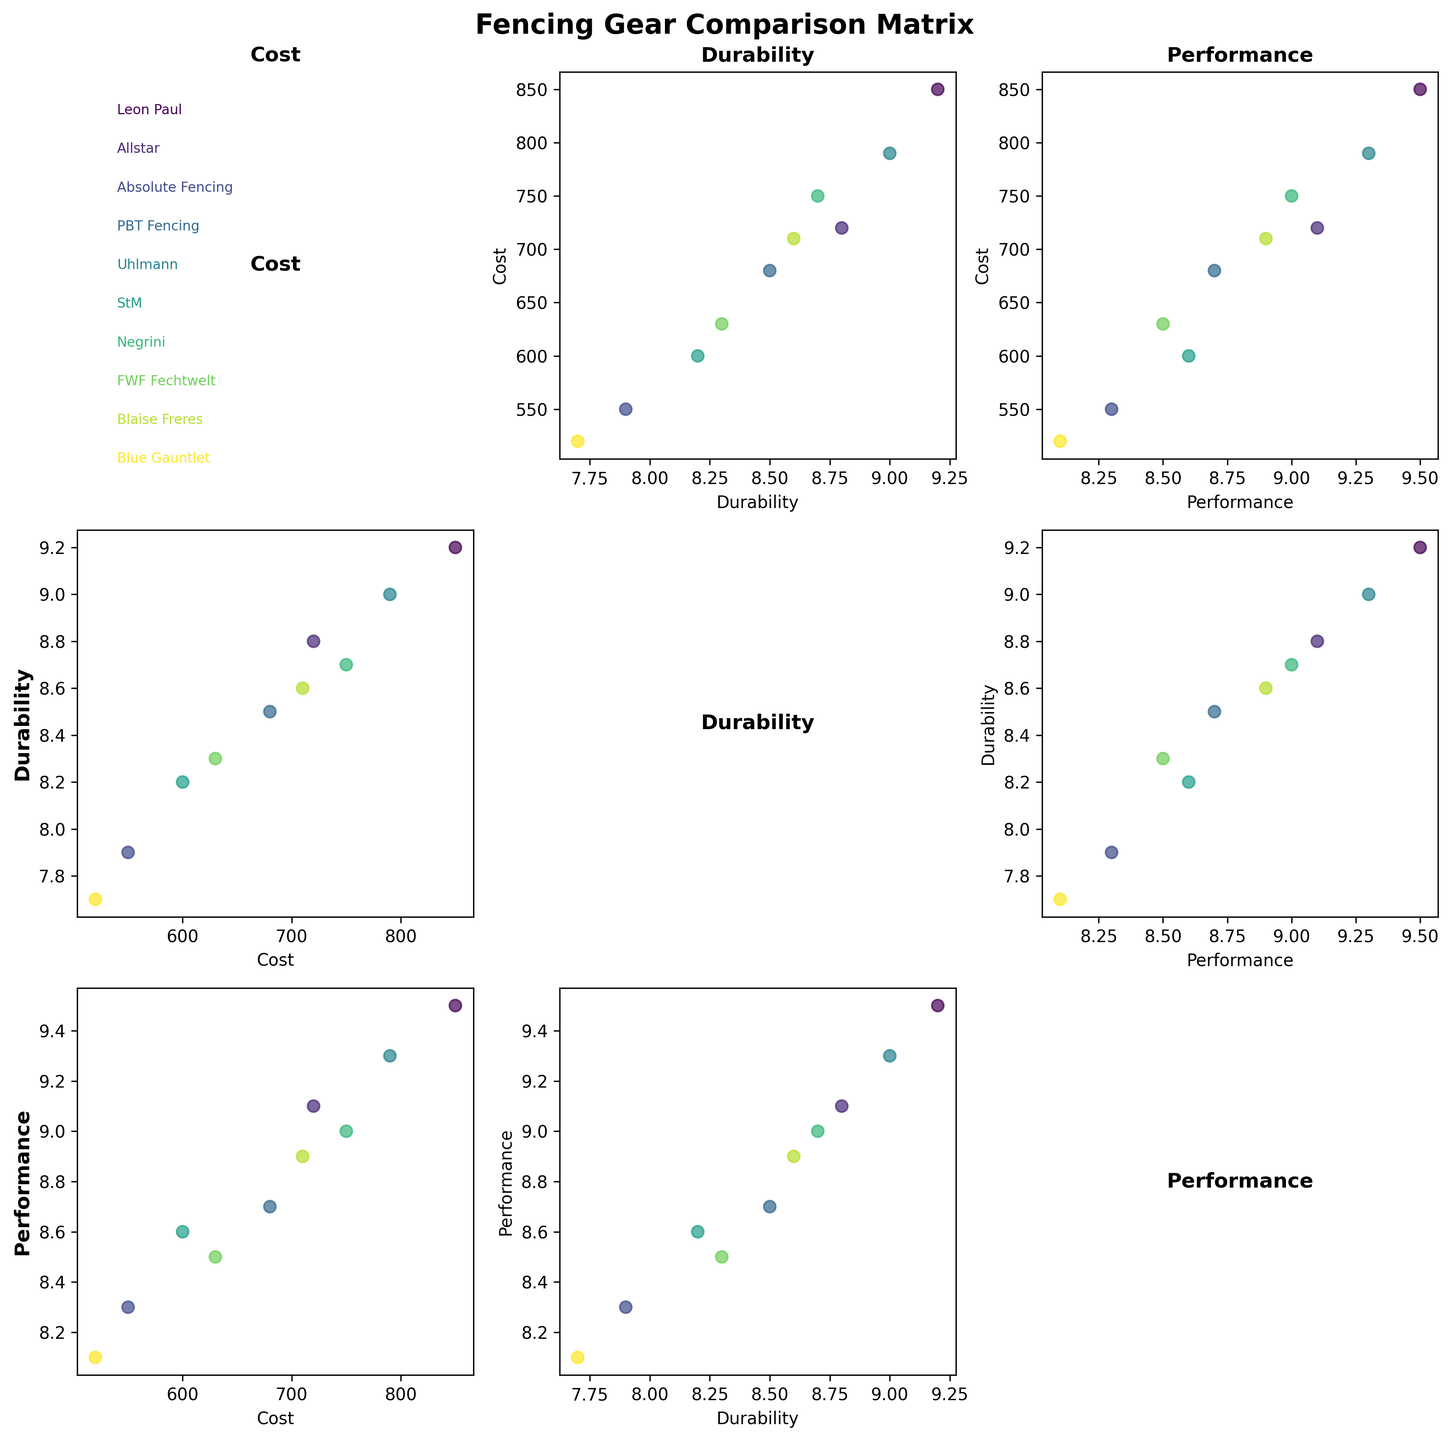What's the title of the figure? The title of the figure is displayed prominently at the top and usually summarizes the main purpose or content of the figure. By looking at the top of the figure, we see the title "Fencing Gear Comparison Matrix".
Answer: Fencing Gear Comparison Matrix How many brands are displayed in the figure? The figure uses colors to represent different brands, and the names of the brands can be found as annotations near the first plot (axes[0,0]). Counting these annotations will give us the total number of brands.
Answer: 10 Which brand has the lowest cost? Look at the scatter plot in the row labeled "Cost" and check for the lowest point in terms of the x-axis (Cost). The point with the lowest x-value corresponds to "Blue Gauntlet" with a cost of 520.
Answer: Blue Gauntlet Which two brands have the highest performance ratings and what are those ratings? Look at the scatter plot in the "Performance" row (y-axis) and identify the two highest points. "Leon Paul" and "Uhlmann" have the highest performance ratings. Their performance ratings are visible on the y-axis in those plots, and we see they are both in the range of about 9.5 and 9.3 respectively.
Answer: Leon Paul (9.5), Uhlmann (9.3) Is there a brand that ranks equally in both durability and performance? To find a brand with equal ranks, look for points on the scatter plot (Durability vs. Performance) that lie along the line where the x and y values are the same. This can involve checking exact numerical comparisons for the brands in this scatter plot. None of the brands appears to lie on such a line directly.
Answer: No Which brand is more cost-effective when considering durability: "Absolute Fencing" or "PBT Fencing"? To determine cost-effectiveness considering durability, look at both the Costs and Durability scatter plots for these brands. "Absolute Fencing" has a cost of 550 and durability of 7.9, while "PBT Fencing" has a cost of 680 and durability of 8.5. In terms of cost per durability unit, Absolute Fencing is more cost-effective (550/7.9 < 680/8.5).
Answer: Absolute Fencing What is the general trend observed between Cost and Performance across brands? Examine the scatter plot matrix between Cost (x-axis) and Performance (y-axis). By looking at the correlation of points, one can observe the trend. Generally, brands with higher costs tend to have better performance ratings (the scatter points show a positive correlation).
Answer: Positive correlation Which brand has similar cost but different durability when compared to "Negrini"? Check the Cost vs Durability scatter points around Negrini's cost (around 750) and look for other points in the same range with different y-values for durability. "Leon Paul" (cost 850) and "Uhlmann" (cost 790) are close in cost but have different durabilities (9.2 and 9.0 respectively).
Answer: Uhlmann (790), Leon Paul (850) Are there any pairs of brands that have a similar performance but widely different costs? Look at the Performance vs. Cost scatter plot for pairs of points that align closely on the y-axis (Performance) but have wide separation on the x-axis (Cost). "Leon Paul" (performance 9.5) and "Absolute Fencing" (performance 8.3) have quite different costs (850 vs. 550), which represents a significant disparity.
Answer: Yes, Leon Paul and Absolute Fencing 